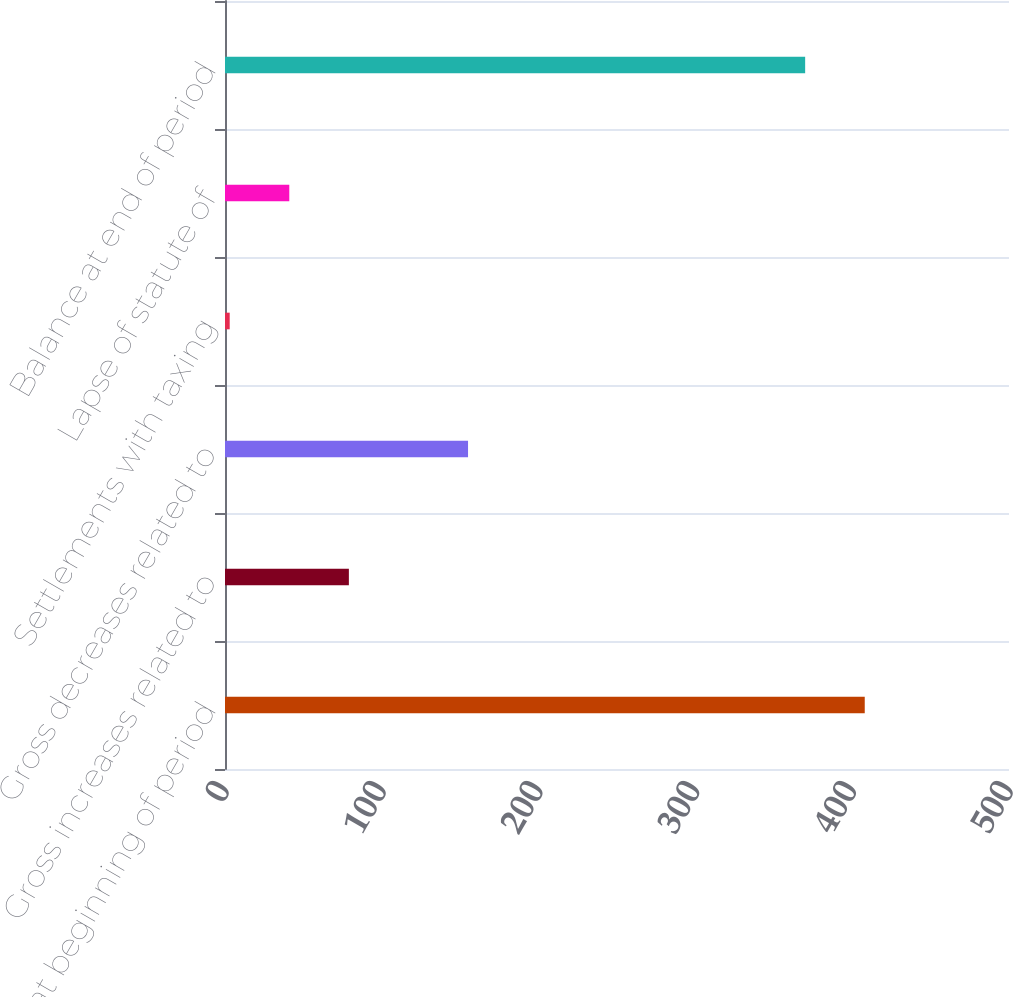<chart> <loc_0><loc_0><loc_500><loc_500><bar_chart><fcel>Balance at beginning of period<fcel>Gross increases related to<fcel>Gross decreases related to<fcel>Settlements with taxing<fcel>Lapse of statute of<fcel>Balance at end of period<nl><fcel>408<fcel>79<fcel>155<fcel>3<fcel>41<fcel>370<nl></chart> 